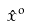Convert formula to latex. <formula><loc_0><loc_0><loc_500><loc_500>\hat { x } ^ { o }</formula> 